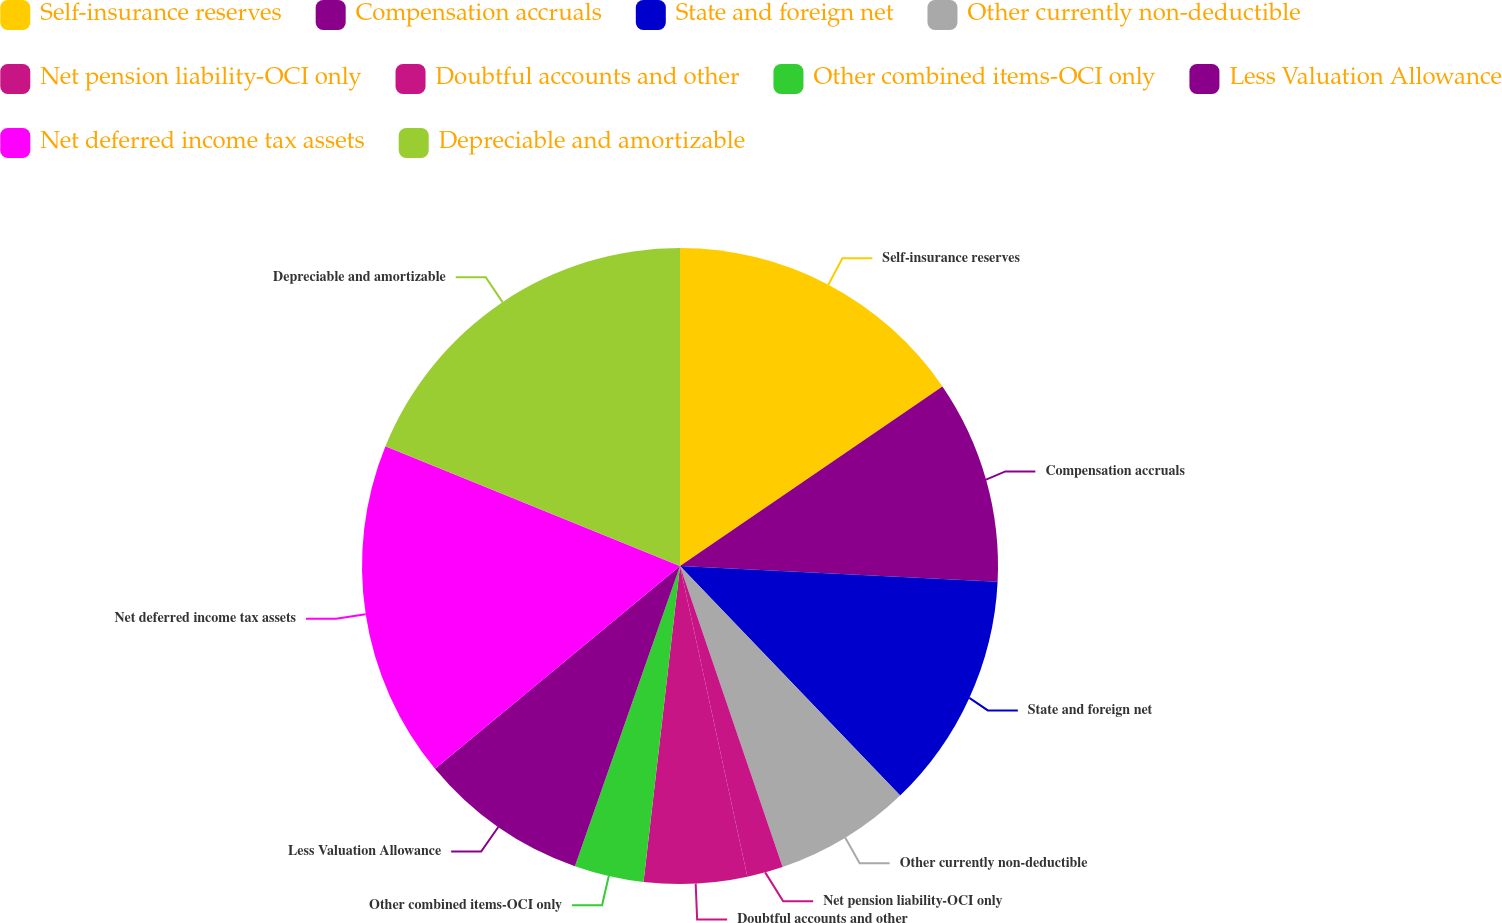Convert chart. <chart><loc_0><loc_0><loc_500><loc_500><pie_chart><fcel>Self-insurance reserves<fcel>Compensation accruals<fcel>State and foreign net<fcel>Other currently non-deductible<fcel>Net pension liability-OCI only<fcel>Doubtful accounts and other<fcel>Other combined items-OCI only<fcel>Less Valuation Allowance<fcel>Net deferred income tax assets<fcel>Depreciable and amortizable<nl><fcel>15.45%<fcel>10.34%<fcel>12.04%<fcel>6.94%<fcel>1.83%<fcel>5.23%<fcel>3.53%<fcel>8.64%<fcel>17.15%<fcel>18.85%<nl></chart> 